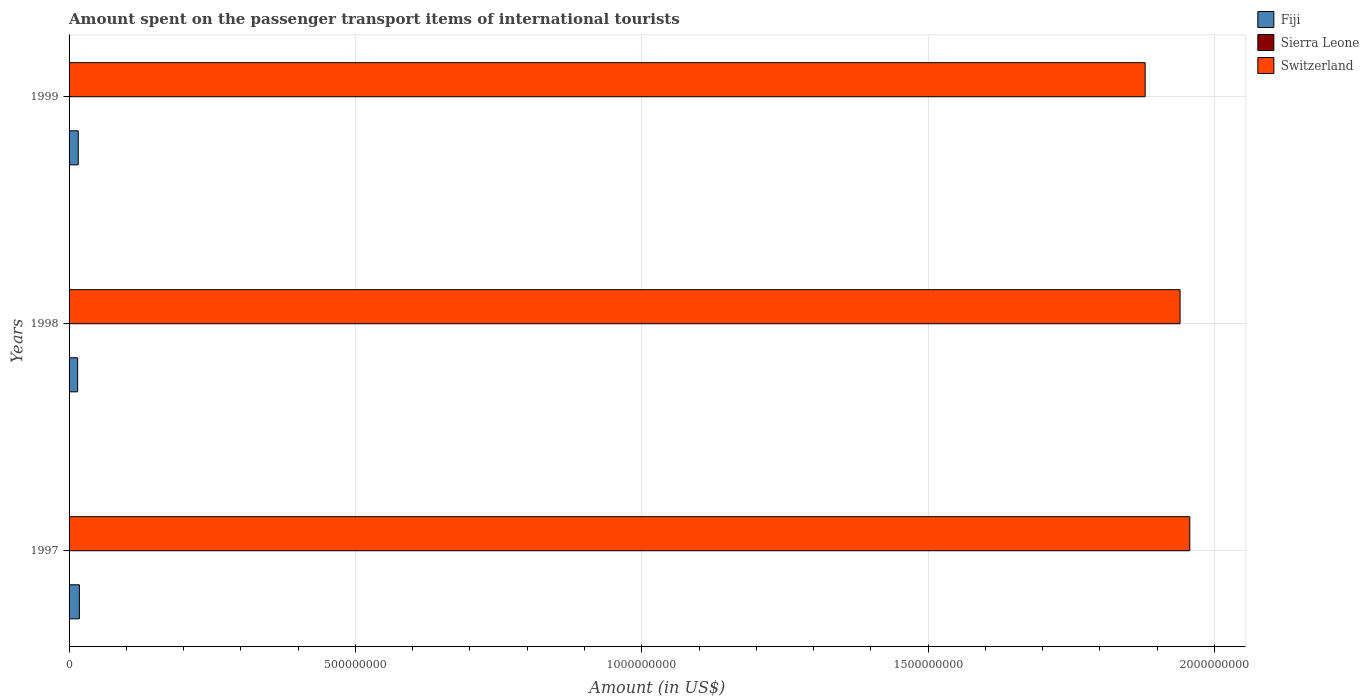How many different coloured bars are there?
Offer a terse response. 3. Are the number of bars per tick equal to the number of legend labels?
Provide a succinct answer. Yes. How many bars are there on the 2nd tick from the bottom?
Your answer should be compact. 3. In how many cases, is the number of bars for a given year not equal to the number of legend labels?
Make the answer very short. 0. What is the amount spent on the passenger transport items of international tourists in Switzerland in 1998?
Offer a terse response. 1.94e+09. Across all years, what is the maximum amount spent on the passenger transport items of international tourists in Switzerland?
Provide a short and direct response. 1.96e+09. Across all years, what is the minimum amount spent on the passenger transport items of international tourists in Switzerland?
Your answer should be very brief. 1.88e+09. In which year was the amount spent on the passenger transport items of international tourists in Sierra Leone maximum?
Your answer should be compact. 1998. In which year was the amount spent on the passenger transport items of international tourists in Fiji minimum?
Ensure brevity in your answer.  1998. What is the total amount spent on the passenger transport items of international tourists in Fiji in the graph?
Give a very brief answer. 4.90e+07. What is the difference between the amount spent on the passenger transport items of international tourists in Switzerland in 1998 and that in 1999?
Ensure brevity in your answer.  6.10e+07. What is the difference between the amount spent on the passenger transport items of international tourists in Switzerland in 1997 and the amount spent on the passenger transport items of international tourists in Sierra Leone in 1998?
Your answer should be very brief. 1.96e+09. What is the average amount spent on the passenger transport items of international tourists in Fiji per year?
Provide a short and direct response. 1.63e+07. In the year 1997, what is the difference between the amount spent on the passenger transport items of international tourists in Sierra Leone and amount spent on the passenger transport items of international tourists in Fiji?
Your answer should be very brief. -1.79e+07. In how many years, is the amount spent on the passenger transport items of international tourists in Switzerland greater than 700000000 US$?
Your answer should be very brief. 3. What is the ratio of the amount spent on the passenger transport items of international tourists in Sierra Leone in 1997 to that in 1998?
Provide a succinct answer. 0.5. Is the difference between the amount spent on the passenger transport items of international tourists in Sierra Leone in 1997 and 1998 greater than the difference between the amount spent on the passenger transport items of international tourists in Fiji in 1997 and 1998?
Offer a terse response. No. What is the difference between the highest and the lowest amount spent on the passenger transport items of international tourists in Sierra Leone?
Offer a very short reply. 1.00e+05. In how many years, is the amount spent on the passenger transport items of international tourists in Switzerland greater than the average amount spent on the passenger transport items of international tourists in Switzerland taken over all years?
Your answer should be compact. 2. Is the sum of the amount spent on the passenger transport items of international tourists in Sierra Leone in 1997 and 1999 greater than the maximum amount spent on the passenger transport items of international tourists in Switzerland across all years?
Your answer should be compact. No. What does the 1st bar from the top in 1997 represents?
Give a very brief answer. Switzerland. What does the 1st bar from the bottom in 1999 represents?
Make the answer very short. Fiji. Is it the case that in every year, the sum of the amount spent on the passenger transport items of international tourists in Sierra Leone and amount spent on the passenger transport items of international tourists in Fiji is greater than the amount spent on the passenger transport items of international tourists in Switzerland?
Provide a short and direct response. No. How many bars are there?
Make the answer very short. 9. Does the graph contain any zero values?
Provide a succinct answer. No. Does the graph contain grids?
Give a very brief answer. Yes. Where does the legend appear in the graph?
Your answer should be very brief. Top right. How many legend labels are there?
Make the answer very short. 3. What is the title of the graph?
Provide a succinct answer. Amount spent on the passenger transport items of international tourists. What is the label or title of the Y-axis?
Offer a very short reply. Years. What is the Amount (in US$) of Fiji in 1997?
Keep it short and to the point. 1.80e+07. What is the Amount (in US$) of Switzerland in 1997?
Give a very brief answer. 1.96e+09. What is the Amount (in US$) in Fiji in 1998?
Give a very brief answer. 1.50e+07. What is the Amount (in US$) in Sierra Leone in 1998?
Your answer should be compact. 2.00e+05. What is the Amount (in US$) of Switzerland in 1998?
Your answer should be very brief. 1.94e+09. What is the Amount (in US$) of Fiji in 1999?
Provide a short and direct response. 1.60e+07. What is the Amount (in US$) of Sierra Leone in 1999?
Your answer should be very brief. 2.00e+05. What is the Amount (in US$) of Switzerland in 1999?
Offer a terse response. 1.88e+09. Across all years, what is the maximum Amount (in US$) in Fiji?
Keep it short and to the point. 1.80e+07. Across all years, what is the maximum Amount (in US$) in Sierra Leone?
Keep it short and to the point. 2.00e+05. Across all years, what is the maximum Amount (in US$) of Switzerland?
Offer a very short reply. 1.96e+09. Across all years, what is the minimum Amount (in US$) of Fiji?
Provide a succinct answer. 1.50e+07. Across all years, what is the minimum Amount (in US$) of Switzerland?
Your answer should be very brief. 1.88e+09. What is the total Amount (in US$) in Fiji in the graph?
Ensure brevity in your answer.  4.90e+07. What is the total Amount (in US$) of Sierra Leone in the graph?
Offer a terse response. 5.00e+05. What is the total Amount (in US$) in Switzerland in the graph?
Give a very brief answer. 5.78e+09. What is the difference between the Amount (in US$) of Fiji in 1997 and that in 1998?
Offer a very short reply. 3.00e+06. What is the difference between the Amount (in US$) in Switzerland in 1997 and that in 1998?
Your answer should be very brief. 1.70e+07. What is the difference between the Amount (in US$) of Fiji in 1997 and that in 1999?
Your response must be concise. 2.00e+06. What is the difference between the Amount (in US$) in Switzerland in 1997 and that in 1999?
Ensure brevity in your answer.  7.80e+07. What is the difference between the Amount (in US$) of Fiji in 1998 and that in 1999?
Keep it short and to the point. -1.00e+06. What is the difference between the Amount (in US$) in Sierra Leone in 1998 and that in 1999?
Ensure brevity in your answer.  0. What is the difference between the Amount (in US$) in Switzerland in 1998 and that in 1999?
Your answer should be compact. 6.10e+07. What is the difference between the Amount (in US$) of Fiji in 1997 and the Amount (in US$) of Sierra Leone in 1998?
Provide a succinct answer. 1.78e+07. What is the difference between the Amount (in US$) of Fiji in 1997 and the Amount (in US$) of Switzerland in 1998?
Offer a terse response. -1.92e+09. What is the difference between the Amount (in US$) of Sierra Leone in 1997 and the Amount (in US$) of Switzerland in 1998?
Your response must be concise. -1.94e+09. What is the difference between the Amount (in US$) in Fiji in 1997 and the Amount (in US$) in Sierra Leone in 1999?
Give a very brief answer. 1.78e+07. What is the difference between the Amount (in US$) in Fiji in 1997 and the Amount (in US$) in Switzerland in 1999?
Make the answer very short. -1.86e+09. What is the difference between the Amount (in US$) of Sierra Leone in 1997 and the Amount (in US$) of Switzerland in 1999?
Your answer should be very brief. -1.88e+09. What is the difference between the Amount (in US$) of Fiji in 1998 and the Amount (in US$) of Sierra Leone in 1999?
Your response must be concise. 1.48e+07. What is the difference between the Amount (in US$) in Fiji in 1998 and the Amount (in US$) in Switzerland in 1999?
Give a very brief answer. -1.86e+09. What is the difference between the Amount (in US$) in Sierra Leone in 1998 and the Amount (in US$) in Switzerland in 1999?
Give a very brief answer. -1.88e+09. What is the average Amount (in US$) in Fiji per year?
Make the answer very short. 1.63e+07. What is the average Amount (in US$) of Sierra Leone per year?
Offer a very short reply. 1.67e+05. What is the average Amount (in US$) of Switzerland per year?
Offer a very short reply. 1.93e+09. In the year 1997, what is the difference between the Amount (in US$) of Fiji and Amount (in US$) of Sierra Leone?
Provide a short and direct response. 1.79e+07. In the year 1997, what is the difference between the Amount (in US$) of Fiji and Amount (in US$) of Switzerland?
Your answer should be very brief. -1.94e+09. In the year 1997, what is the difference between the Amount (in US$) in Sierra Leone and Amount (in US$) in Switzerland?
Provide a succinct answer. -1.96e+09. In the year 1998, what is the difference between the Amount (in US$) of Fiji and Amount (in US$) of Sierra Leone?
Your answer should be very brief. 1.48e+07. In the year 1998, what is the difference between the Amount (in US$) of Fiji and Amount (in US$) of Switzerland?
Keep it short and to the point. -1.92e+09. In the year 1998, what is the difference between the Amount (in US$) in Sierra Leone and Amount (in US$) in Switzerland?
Give a very brief answer. -1.94e+09. In the year 1999, what is the difference between the Amount (in US$) of Fiji and Amount (in US$) of Sierra Leone?
Your answer should be very brief. 1.58e+07. In the year 1999, what is the difference between the Amount (in US$) of Fiji and Amount (in US$) of Switzerland?
Provide a short and direct response. -1.86e+09. In the year 1999, what is the difference between the Amount (in US$) in Sierra Leone and Amount (in US$) in Switzerland?
Provide a succinct answer. -1.88e+09. What is the ratio of the Amount (in US$) of Fiji in 1997 to that in 1998?
Your response must be concise. 1.2. What is the ratio of the Amount (in US$) in Switzerland in 1997 to that in 1998?
Your answer should be compact. 1.01. What is the ratio of the Amount (in US$) of Sierra Leone in 1997 to that in 1999?
Your answer should be compact. 0.5. What is the ratio of the Amount (in US$) in Switzerland in 1997 to that in 1999?
Your answer should be compact. 1.04. What is the ratio of the Amount (in US$) of Sierra Leone in 1998 to that in 1999?
Keep it short and to the point. 1. What is the ratio of the Amount (in US$) of Switzerland in 1998 to that in 1999?
Give a very brief answer. 1.03. What is the difference between the highest and the second highest Amount (in US$) in Fiji?
Keep it short and to the point. 2.00e+06. What is the difference between the highest and the second highest Amount (in US$) in Switzerland?
Provide a succinct answer. 1.70e+07. What is the difference between the highest and the lowest Amount (in US$) of Fiji?
Provide a succinct answer. 3.00e+06. What is the difference between the highest and the lowest Amount (in US$) of Switzerland?
Offer a very short reply. 7.80e+07. 